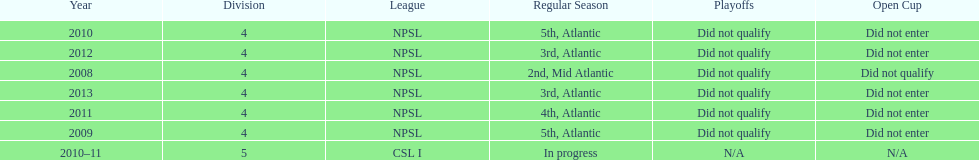How many years did they not qualify for the playoffs? 6. 